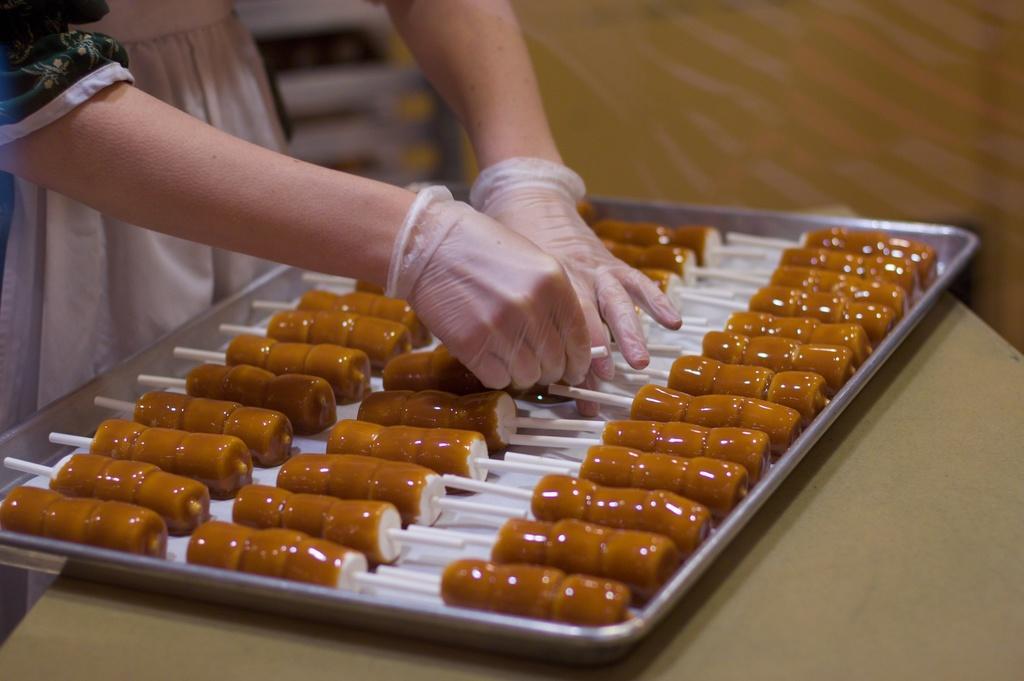Could you give a brief overview of what you see in this image? In this image we can see the candies in a tray which is on the table. We can also see some person wearing the hand gloves on the left. 